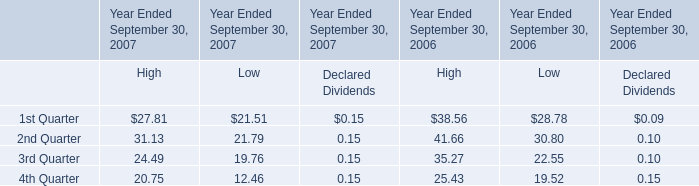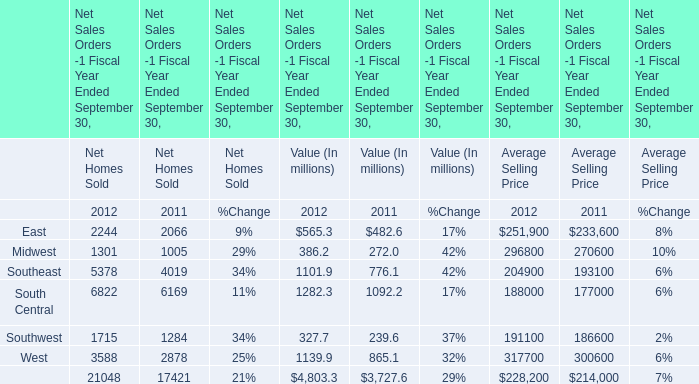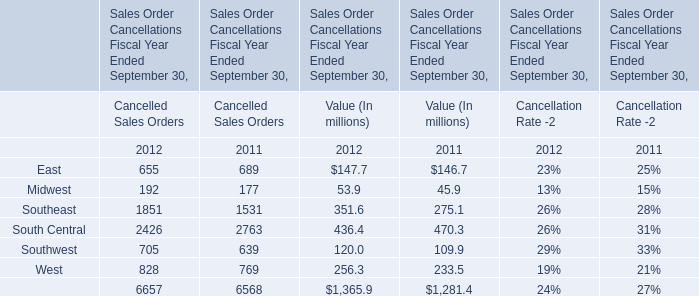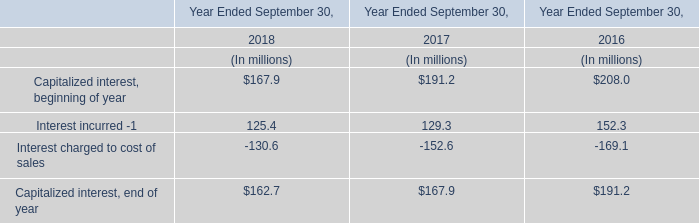What's the growth rate of Midwest in value in 2012? 
Computations: ((386.2 - 272.0) / 272.0)
Answer: 0.41985. 